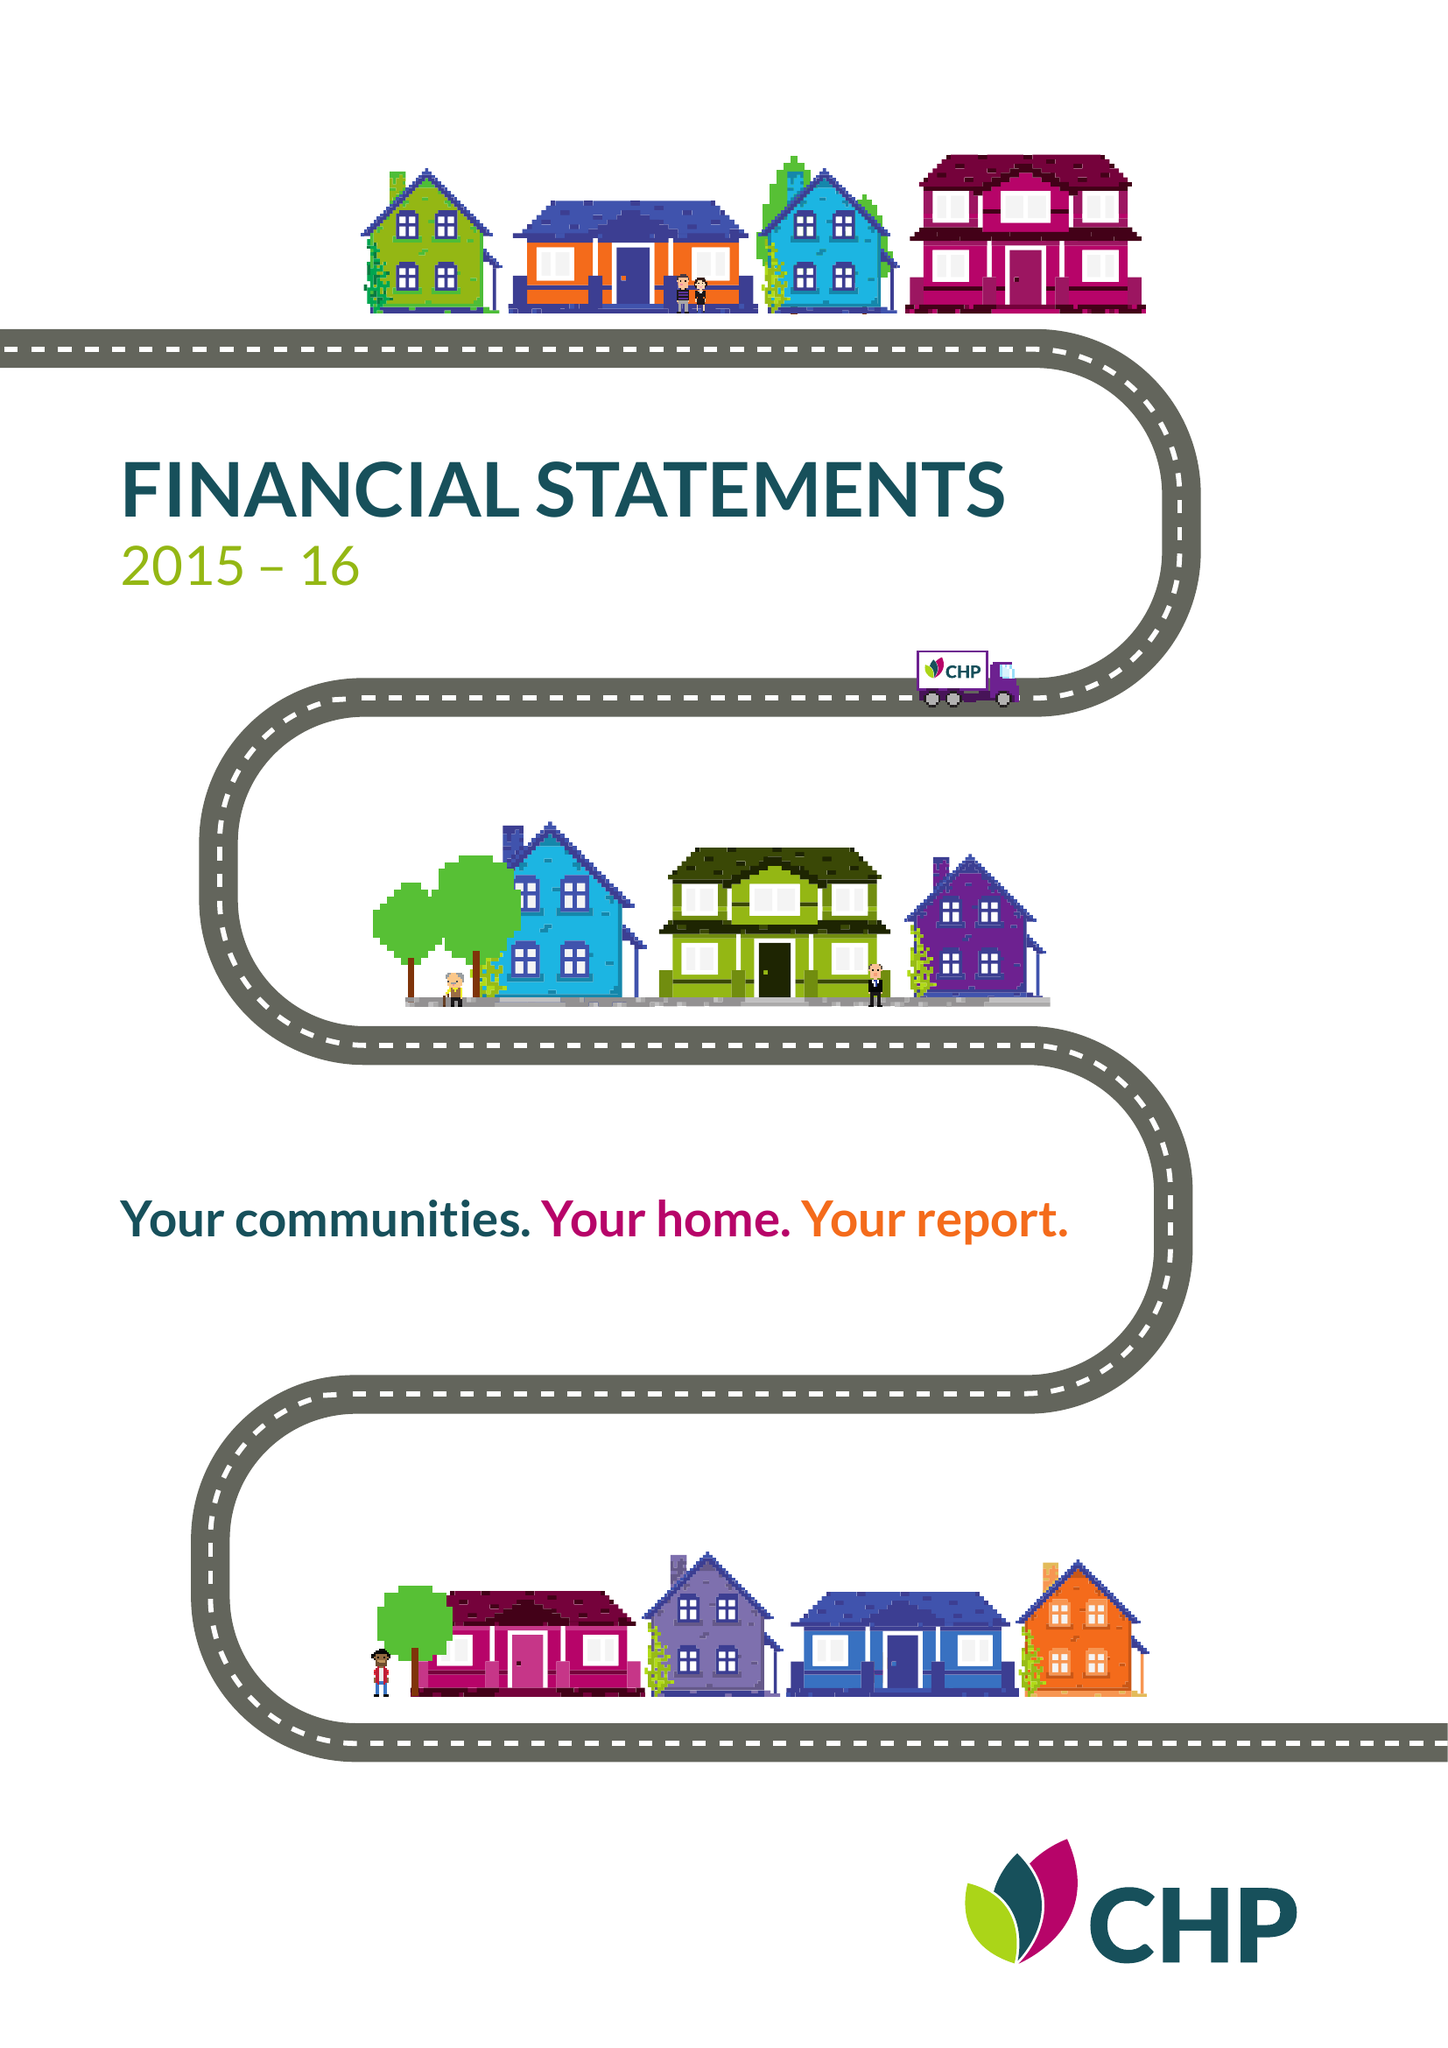What is the value for the address__postcode?
Answer the question using a single word or phrase. CM2 5LB 